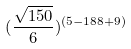Convert formula to latex. <formula><loc_0><loc_0><loc_500><loc_500>( \frac { \sqrt { 1 5 0 } } { 6 } ) ^ { ( 5 - 1 8 8 + 9 ) }</formula> 